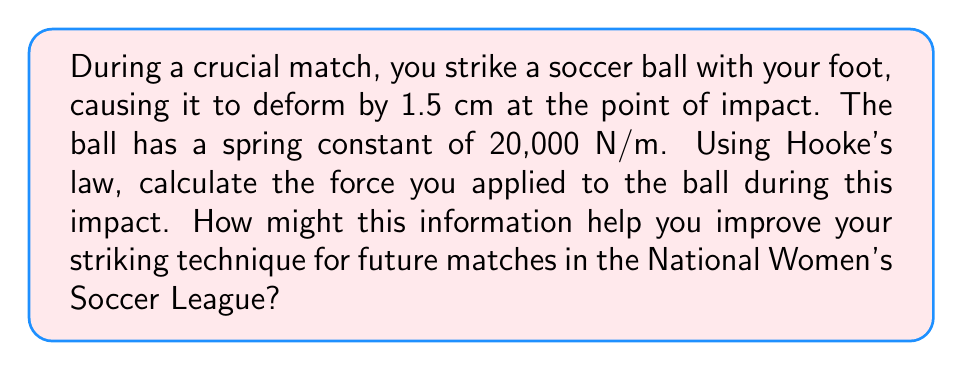Give your solution to this math problem. To solve this problem, we'll use Hooke's law, which relates force to displacement in elastic objects. The steps are as follows:

1) Hooke's law is given by the equation:

   $$F = kx$$

   Where:
   $F$ is the force applied
   $k$ is the spring constant
   $x$ is the displacement (deformation)

2) We're given:
   $k = 20,000$ N/m
   $x = 1.5$ cm = 0.015 m (convert to meters)

3) Substitute these values into the equation:

   $$F = 20,000 \text{ N/m} \times 0.015 \text{ m}$$

4) Calculate:

   $$F = 300 \text{ N}$$

This force of 300 N represents the impact force you applied to the ball. Understanding this can help improve your technique in several ways:

1) It provides a quantitative measure of your striking power, which you can track over time.
2) You can compare this force to that of professional players in the National Women's Soccer League.
3) By adjusting your technique and measuring the resulting force, you can work on optimizing your kick for both power and accuracy.
4) Understanding the relationship between applied force and ball deformation can help you better control the ball in various weather conditions or with different types of soccer balls.
Answer: 300 N 